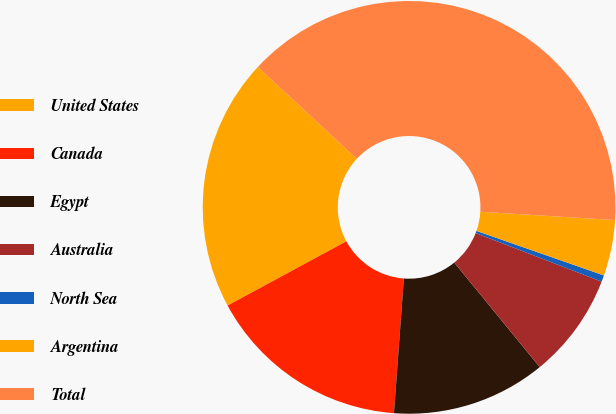Convert chart to OTSL. <chart><loc_0><loc_0><loc_500><loc_500><pie_chart><fcel>United States<fcel>Canada<fcel>Egypt<fcel>Australia<fcel>North Sea<fcel>Argentina<fcel>Total<nl><fcel>19.8%<fcel>15.94%<fcel>12.08%<fcel>8.23%<fcel>0.51%<fcel>4.37%<fcel>39.08%<nl></chart> 